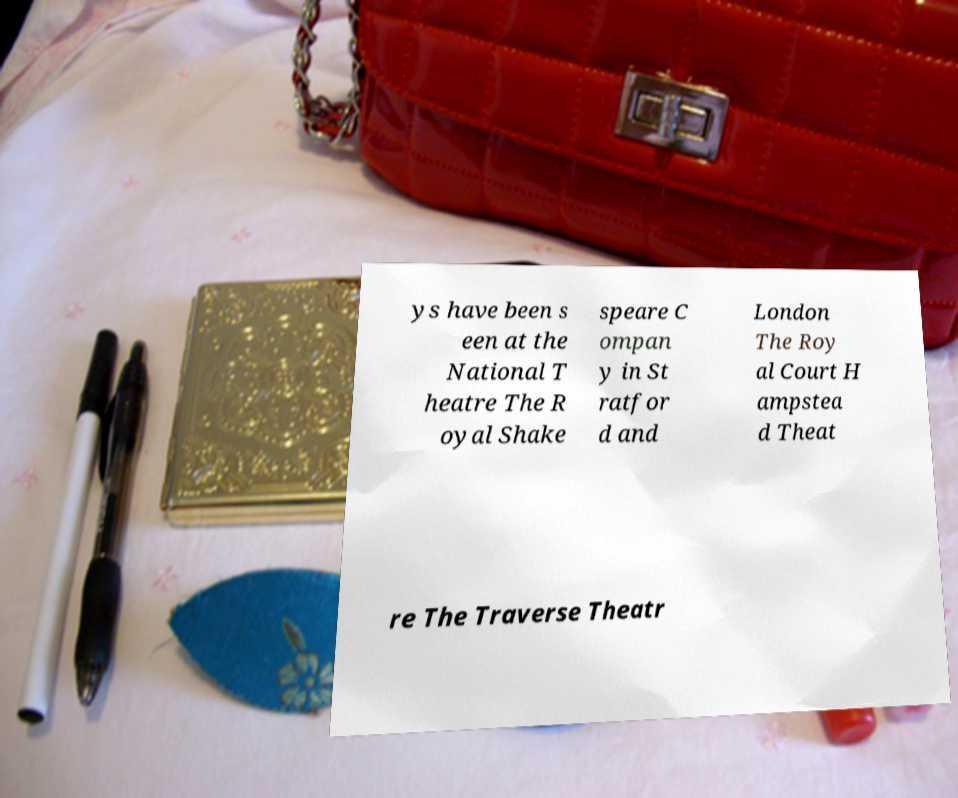For documentation purposes, I need the text within this image transcribed. Could you provide that? ys have been s een at the National T heatre The R oyal Shake speare C ompan y in St ratfor d and London The Roy al Court H ampstea d Theat re The Traverse Theatr 